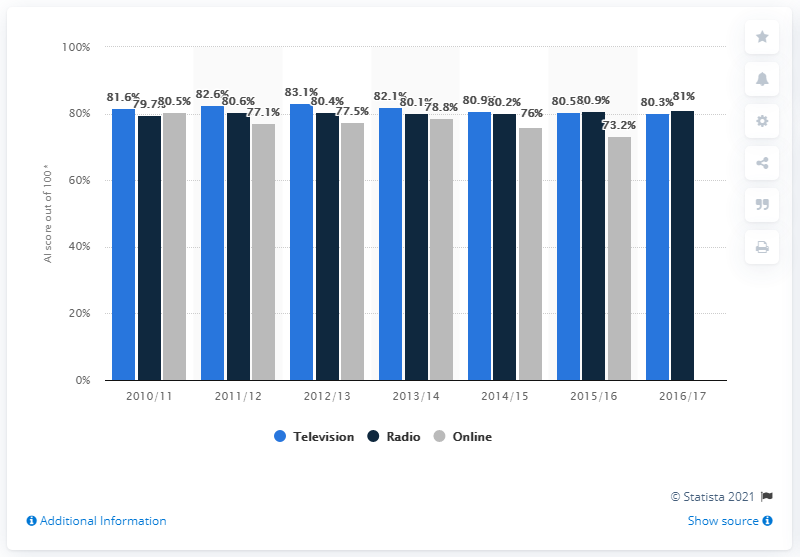Mention a couple of crucial points in this snapshot. In 2013/2014, the average value was 80.33. In 2016/17, the percentage value for radio was 81%. The BBC's fiscal year in the UK ended in 2016/17. The BBC had the highest audience appreciation score in the 2010/2011 season. 